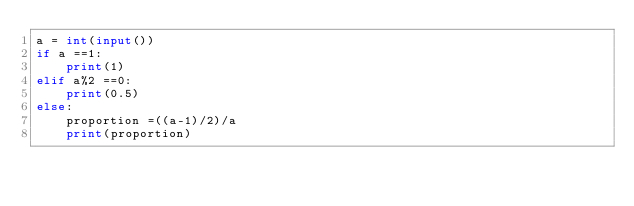<code> <loc_0><loc_0><loc_500><loc_500><_Python_>a = int(input())
if a ==1:
    print(1)
elif a%2 ==0:
    print(0.5)
else:
    proportion =((a-1)/2)/a
    print(proportion)
</code> 